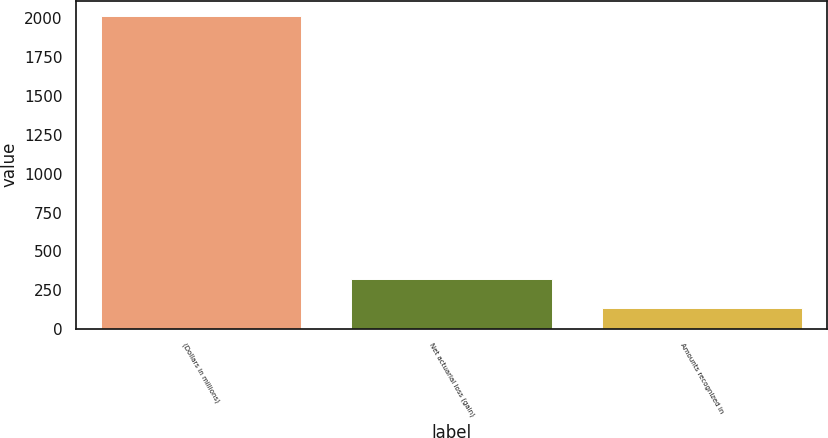Convert chart to OTSL. <chart><loc_0><loc_0><loc_500><loc_500><bar_chart><fcel>(Dollars in millions)<fcel>Net actuarial loss (gain)<fcel>Amounts recognized in<nl><fcel>2015<fcel>322.1<fcel>134<nl></chart> 